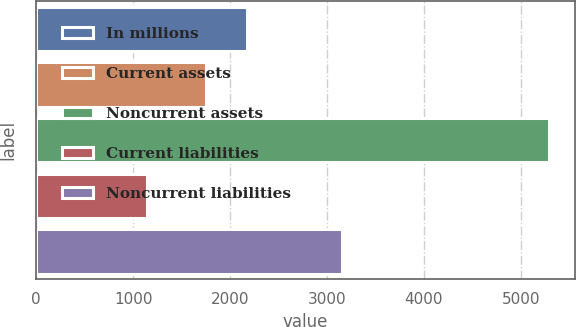<chart> <loc_0><loc_0><loc_500><loc_500><bar_chart><fcel>In millions<fcel>Current assets<fcel>Noncurrent assets<fcel>Current liabilities<fcel>Noncurrent liabilities<nl><fcel>2171.4<fcel>1757<fcel>5292<fcel>1148<fcel>3156<nl></chart> 